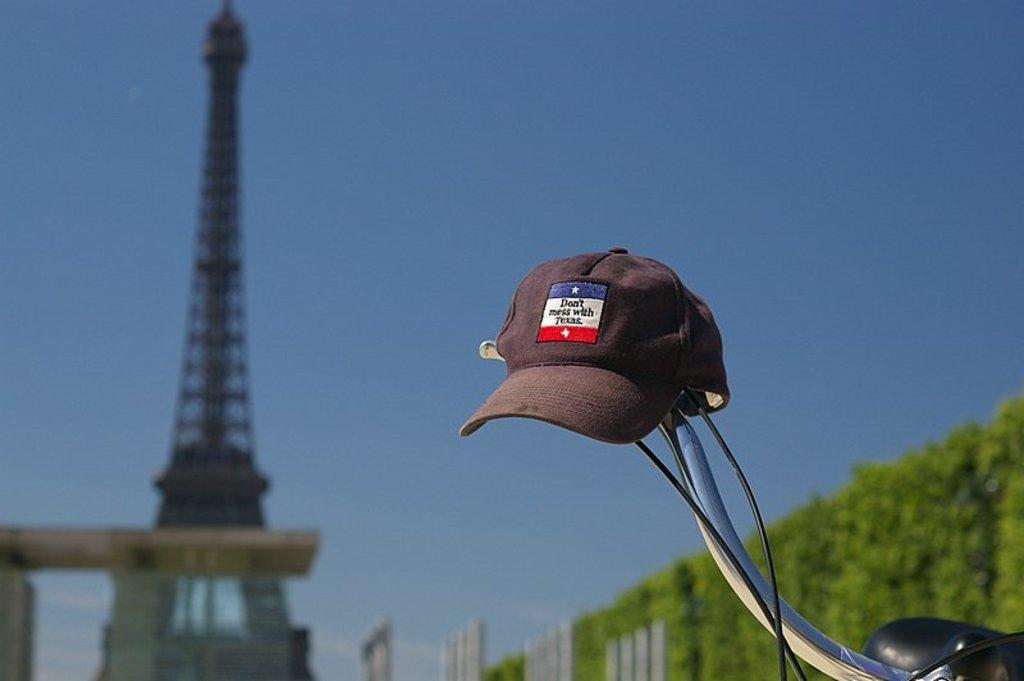What object is placed on the handle of a cycle in the image? There is a cap placed on the handle of a cycle in the image. Where is the tower located in the image? The tower is on the left side of the image. What type of vegetation is on the right side of the image? There are plants on the right side of the image. Can you tell me how many bees are sitting on the cap in the image? There are no bees present in the image, so it is not possible to determine how many bees might be sitting on the cap. 